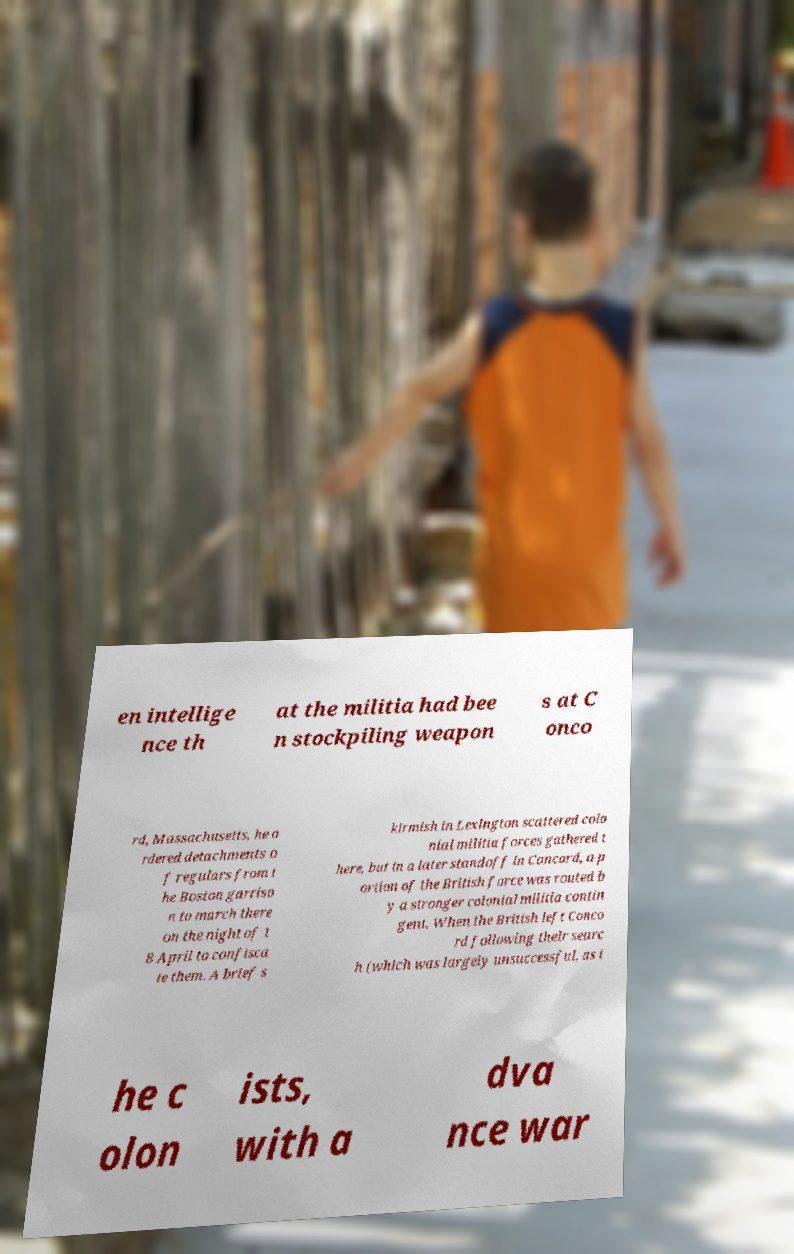There's text embedded in this image that I need extracted. Can you transcribe it verbatim? en intellige nce th at the militia had bee n stockpiling weapon s at C onco rd, Massachusetts, he o rdered detachments o f regulars from t he Boston garriso n to march there on the night of 1 8 April to confisca te them. A brief s kirmish in Lexington scattered colo nial militia forces gathered t here, but in a later standoff in Concord, a p ortion of the British force was routed b y a stronger colonial militia contin gent. When the British left Conco rd following their searc h (which was largely unsuccessful, as t he c olon ists, with a dva nce war 